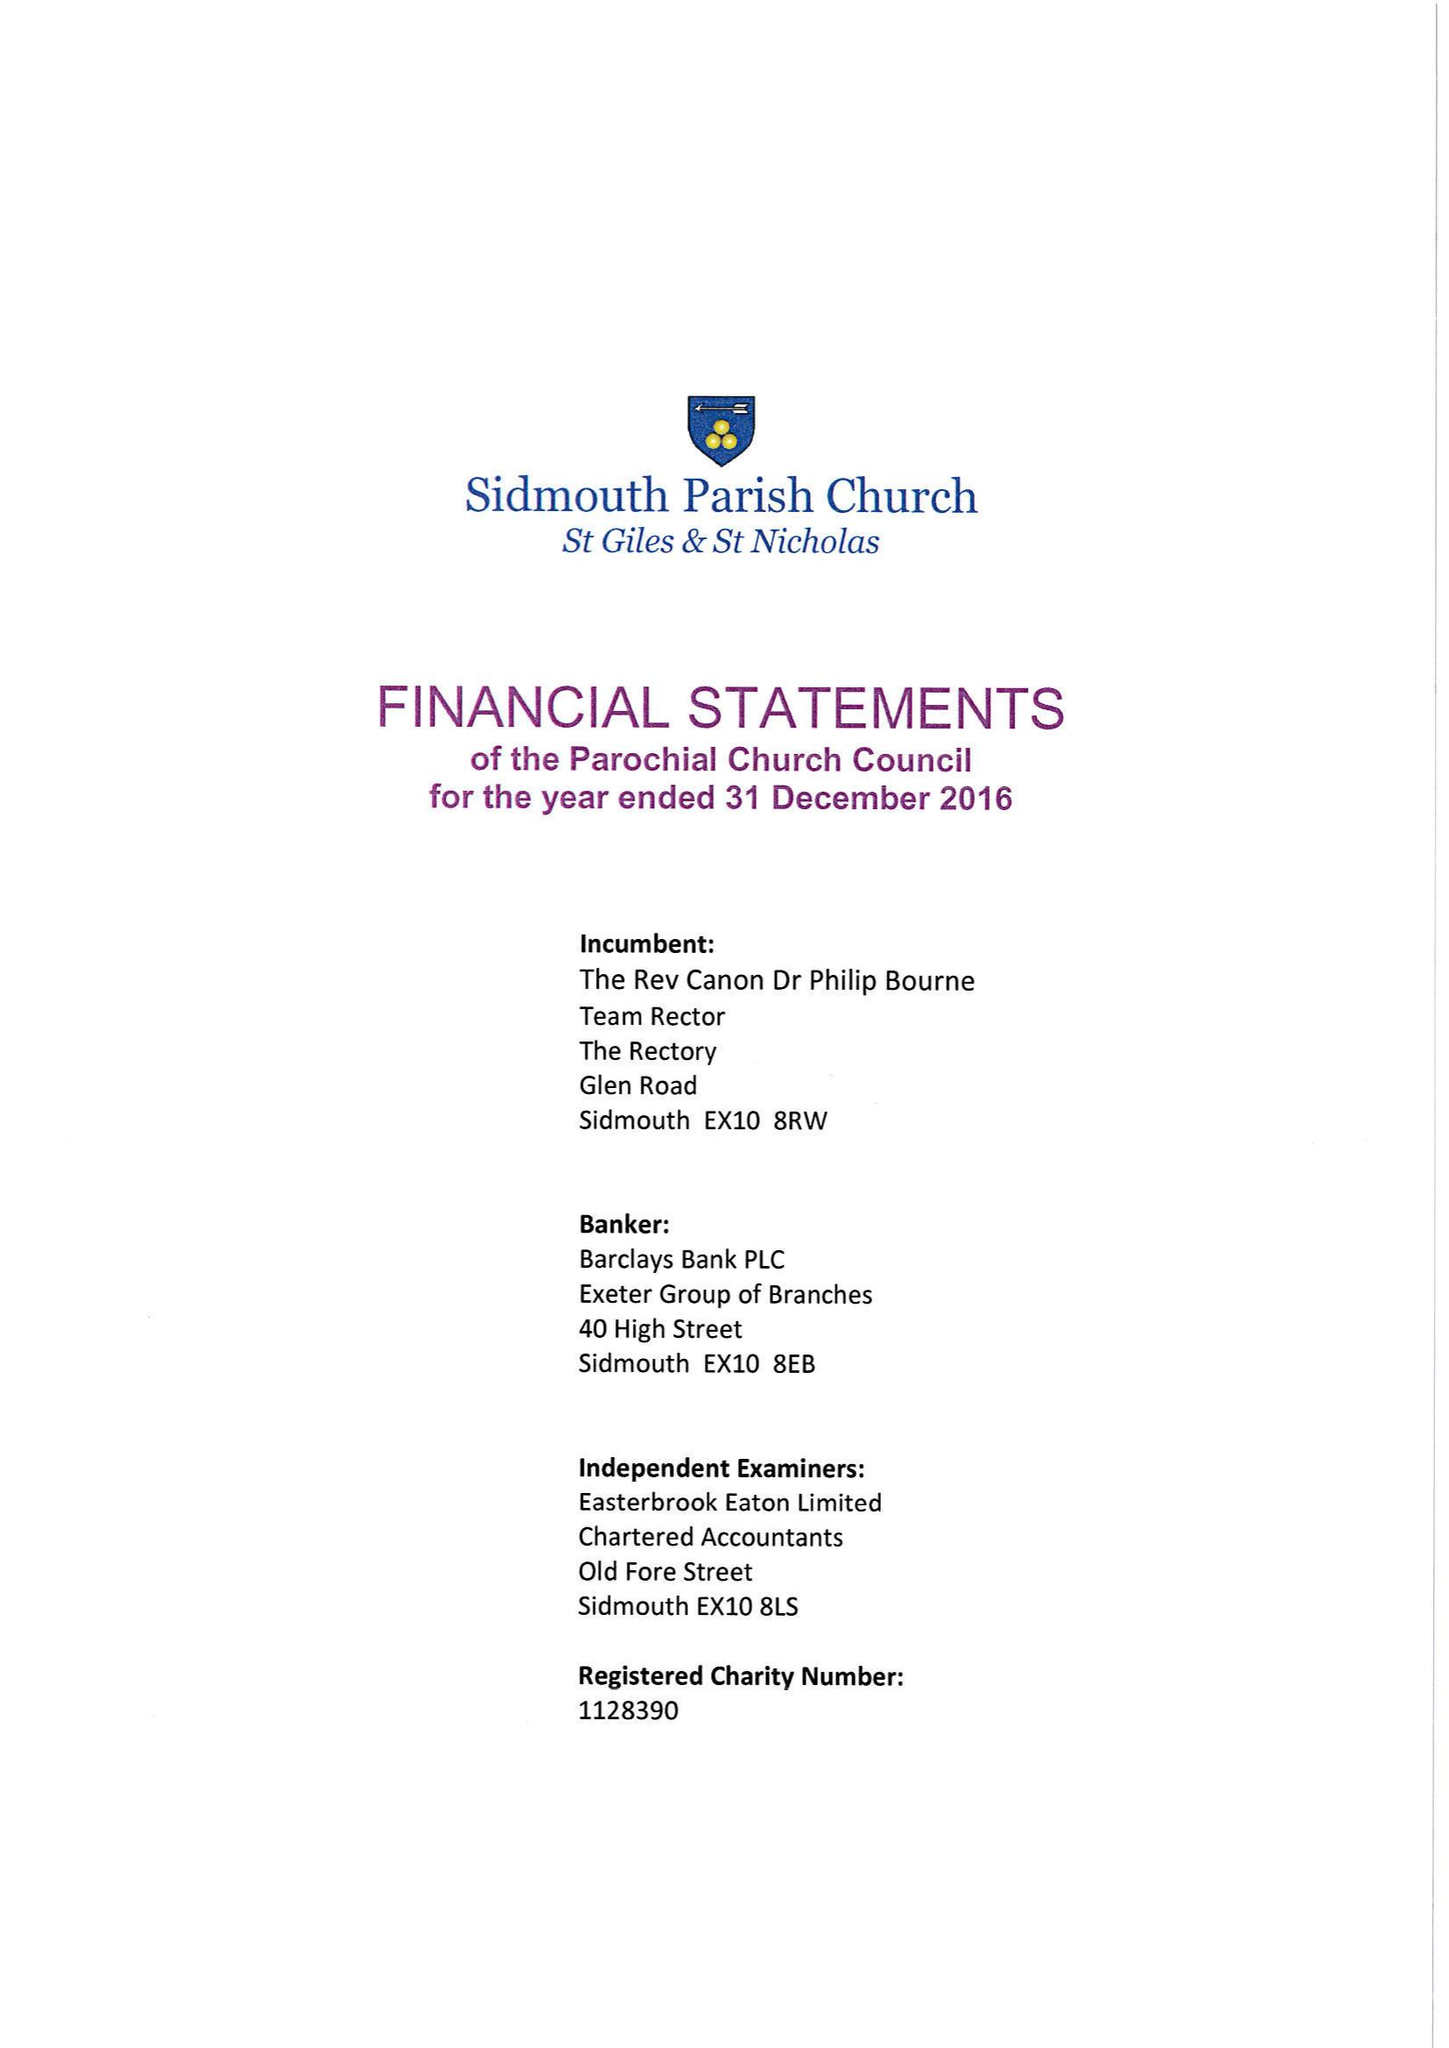What is the value for the charity_name?
Answer the question using a single word or phrase. The Parochial Church Council Of The Ecclesiastical Parish Of Sidmouth Parish Church St Giles and St Nicholas 